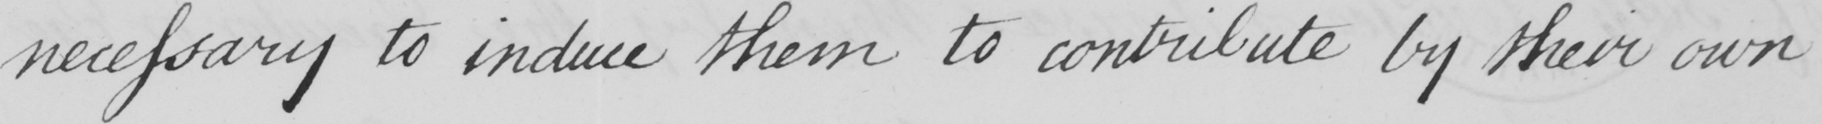Can you read and transcribe this handwriting? necessary to induce them to contribute by their own 